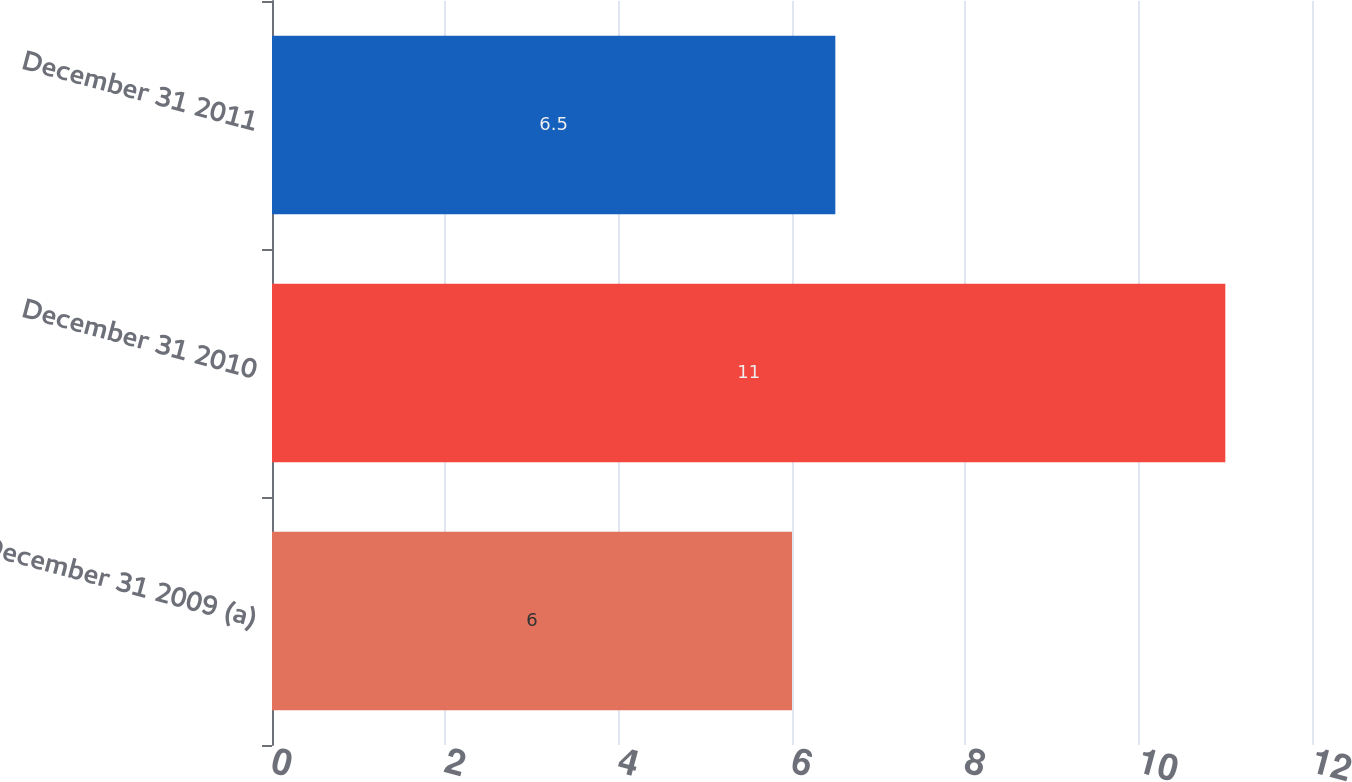Convert chart. <chart><loc_0><loc_0><loc_500><loc_500><bar_chart><fcel>December 31 2009 (a)<fcel>December 31 2010<fcel>December 31 2011<nl><fcel>6<fcel>11<fcel>6.5<nl></chart> 